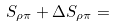<formula> <loc_0><loc_0><loc_500><loc_500>S _ { \rho \pi } + \Delta S _ { \rho \pi } =</formula> 